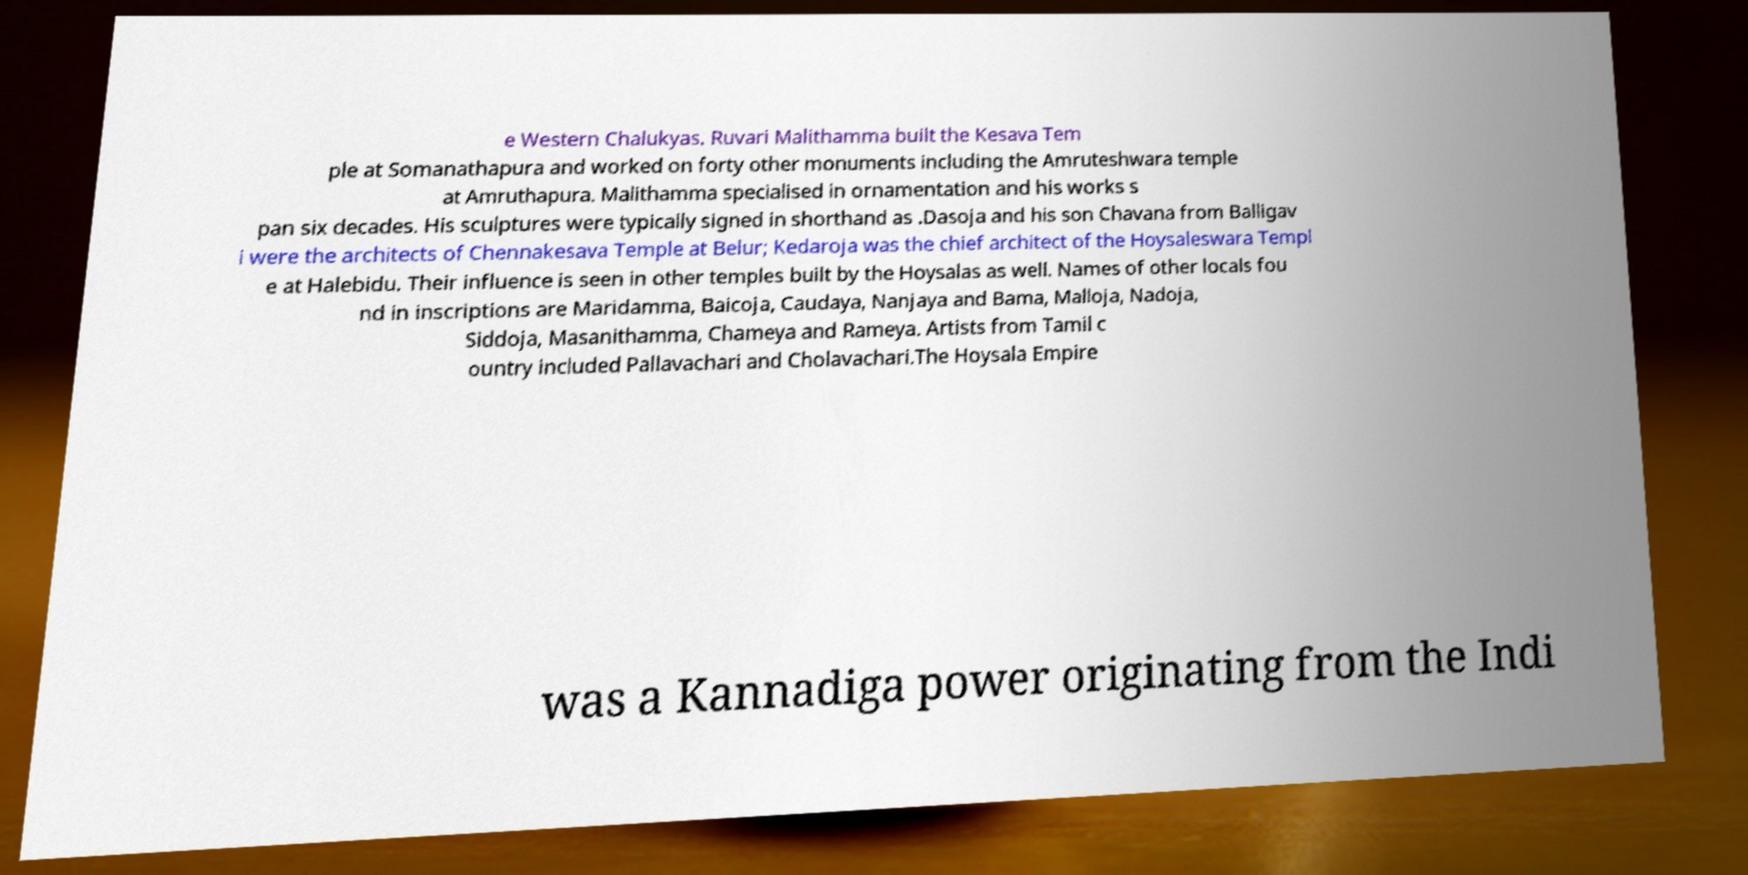Can you accurately transcribe the text from the provided image for me? e Western Chalukyas. Ruvari Malithamma built the Kesava Tem ple at Somanathapura and worked on forty other monuments including the Amruteshwara temple at Amruthapura. Malithamma specialised in ornamentation and his works s pan six decades. His sculptures were typically signed in shorthand as .Dasoja and his son Chavana from Balligav i were the architects of Chennakesava Temple at Belur; Kedaroja was the chief architect of the Hoysaleswara Templ e at Halebidu. Their influence is seen in other temples built by the Hoysalas as well. Names of other locals fou nd in inscriptions are Maridamma, Baicoja, Caudaya, Nanjaya and Bama, Malloja, Nadoja, Siddoja, Masanithamma, Chameya and Rameya. Artists from Tamil c ountry included Pallavachari and Cholavachari.The Hoysala Empire was a Kannadiga power originating from the Indi 